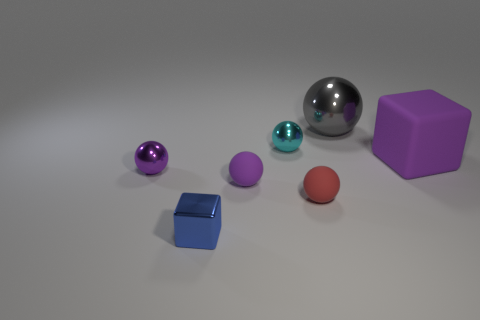Add 1 big brown metallic balls. How many objects exist? 8 Subtract all cubes. How many objects are left? 5 Subtract 1 blue blocks. How many objects are left? 6 Subtract all red matte objects. Subtract all small cyan metallic spheres. How many objects are left? 5 Add 3 purple metal balls. How many purple metal balls are left? 4 Add 5 metallic things. How many metallic things exist? 9 